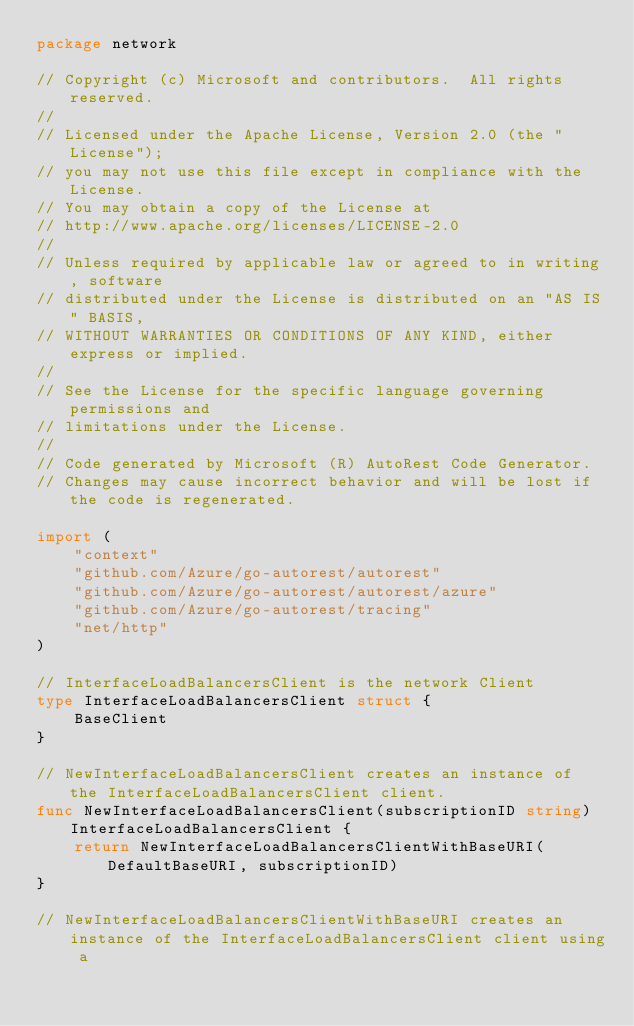Convert code to text. <code><loc_0><loc_0><loc_500><loc_500><_Go_>package network

// Copyright (c) Microsoft and contributors.  All rights reserved.
//
// Licensed under the Apache License, Version 2.0 (the "License");
// you may not use this file except in compliance with the License.
// You may obtain a copy of the License at
// http://www.apache.org/licenses/LICENSE-2.0
//
// Unless required by applicable law or agreed to in writing, software
// distributed under the License is distributed on an "AS IS" BASIS,
// WITHOUT WARRANTIES OR CONDITIONS OF ANY KIND, either express or implied.
//
// See the License for the specific language governing permissions and
// limitations under the License.
//
// Code generated by Microsoft (R) AutoRest Code Generator.
// Changes may cause incorrect behavior and will be lost if the code is regenerated.

import (
	"context"
	"github.com/Azure/go-autorest/autorest"
	"github.com/Azure/go-autorest/autorest/azure"
	"github.com/Azure/go-autorest/tracing"
	"net/http"
)

// InterfaceLoadBalancersClient is the network Client
type InterfaceLoadBalancersClient struct {
	BaseClient
}

// NewInterfaceLoadBalancersClient creates an instance of the InterfaceLoadBalancersClient client.
func NewInterfaceLoadBalancersClient(subscriptionID string) InterfaceLoadBalancersClient {
	return NewInterfaceLoadBalancersClientWithBaseURI(DefaultBaseURI, subscriptionID)
}

// NewInterfaceLoadBalancersClientWithBaseURI creates an instance of the InterfaceLoadBalancersClient client using a</code> 